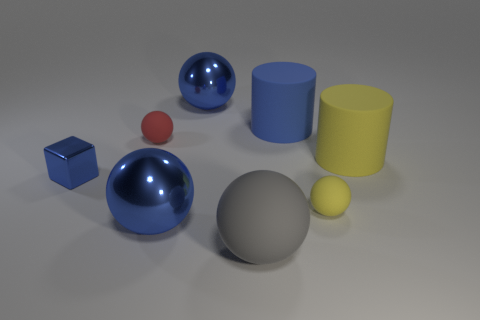How many blue spheres must be subtracted to get 1 blue spheres? 1 Add 2 gray metal cylinders. How many objects exist? 10 Subtract all big matte spheres. How many spheres are left? 4 Subtract 1 cubes. How many cubes are left? 0 Subtract all spheres. How many objects are left? 3 Subtract all red balls. How many balls are left? 4 Subtract all small matte balls. Subtract all small yellow balls. How many objects are left? 5 Add 5 small spheres. How many small spheres are left? 7 Add 3 small green matte cylinders. How many small green matte cylinders exist? 3 Subtract 1 yellow balls. How many objects are left? 7 